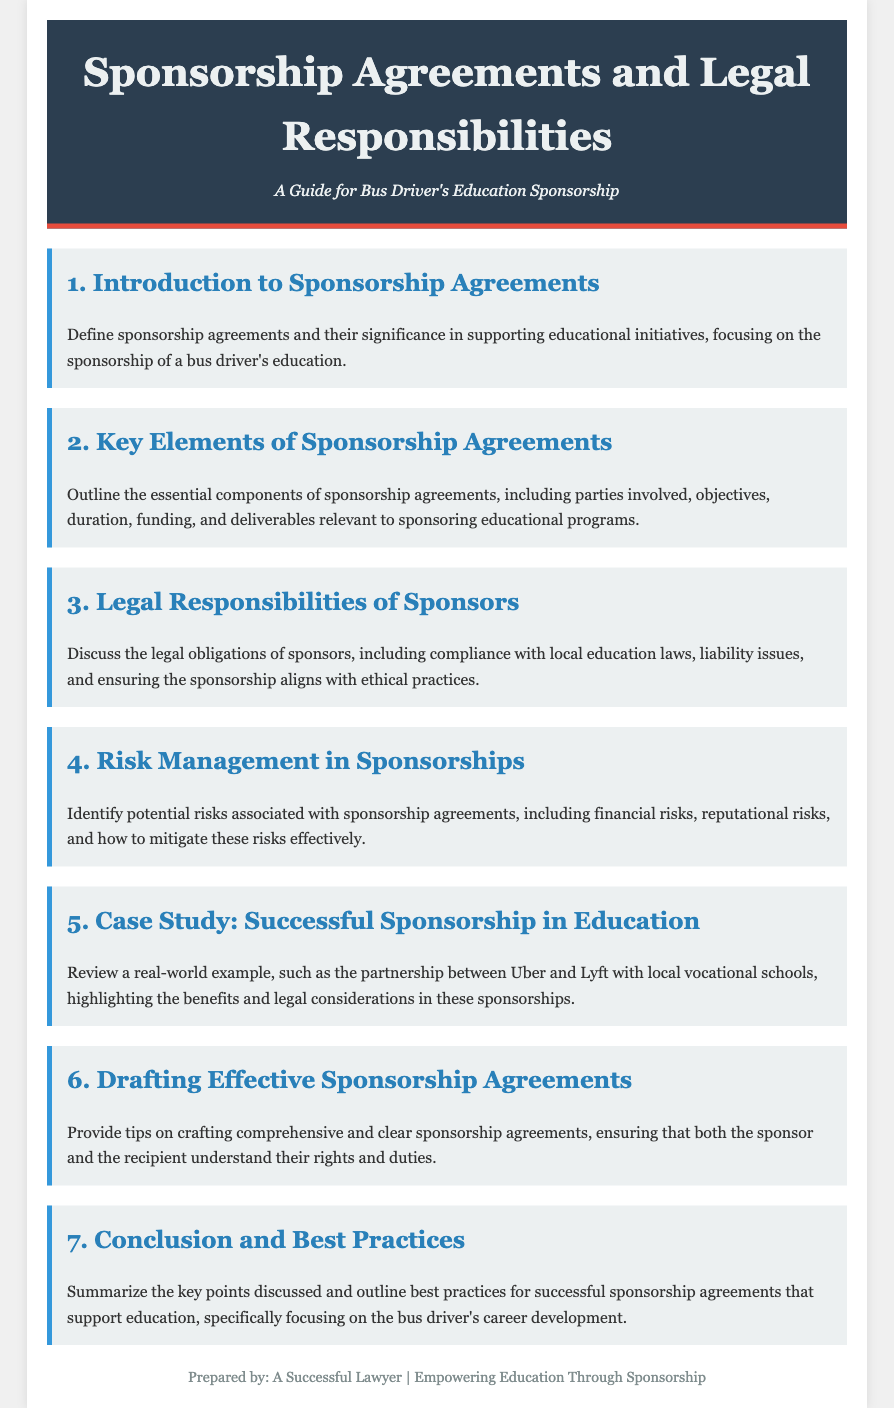What is the title of the document? The title of the document, as stated in the header, relates to sponsorship agreements and legal responsibilities.
Answer: Sponsorship Agreements and Legal Responsibilities What is the primary focus of the sponsorship agreements discussed? The document specifically mentions the sponsorship of a bus driver's education as a significant initiative.
Answer: Bus driver's education What is one key element of sponsorship agreements listed? The agenda outlines essential components, such as duration, objectives, and funding.
Answer: Duration What are sponsors' legal obligations mentioned in the document? The document highlights compliance with local education laws and ethical practices as legal responsibilities.
Answer: Compliance with local education laws Which section discusses risk management? The agenda item that addresses risk management explicitly identifies potential risks associated with sponsorship agreements.
Answer: 4. Risk Management in Sponsorships What example does the case study reference? The document refers to partnerships between Uber and Lyft with local vocational schools as a real-world example of sponsorship in education.
Answer: Uber and Lyft How many agenda items are listed in total? By counting the distinct sections mentioned, the total number of agenda items can be determined.
Answer: 7 What is the main conclusion focus of the final section? The last section summarizes key points and highlights best practices for preparing successful sponsorship agreements.
Answer: Best practices for successful sponsorship agreements 